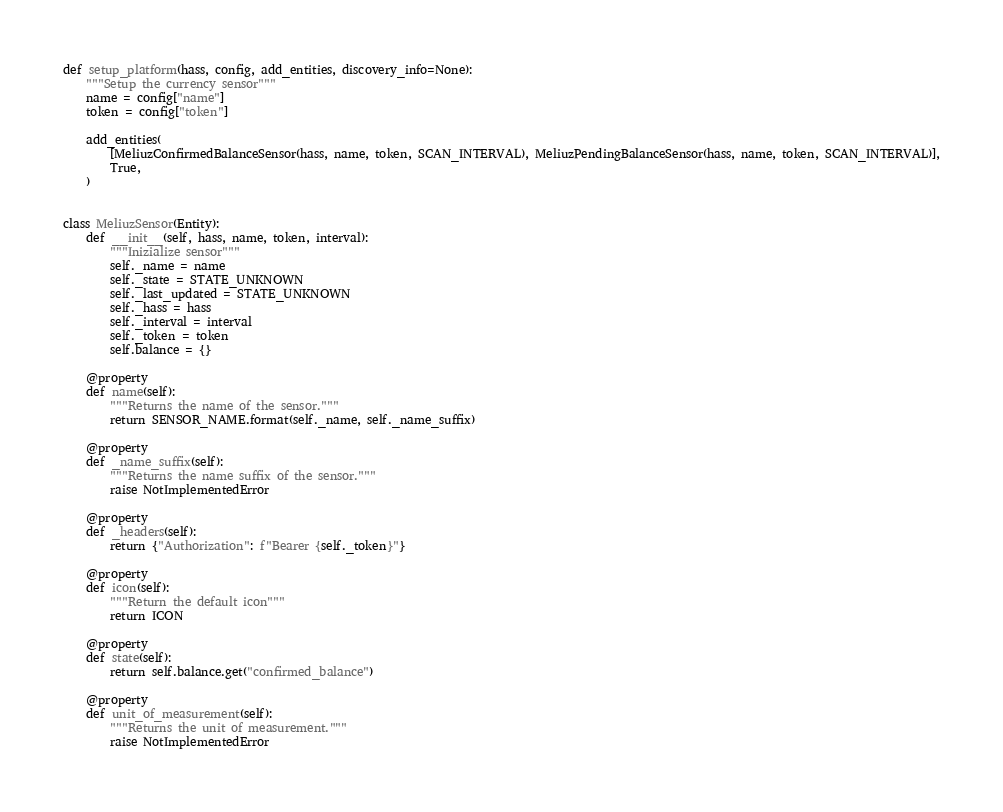Convert code to text. <code><loc_0><loc_0><loc_500><loc_500><_Python_>def setup_platform(hass, config, add_entities, discovery_info=None):
    """Setup the currency sensor"""
    name = config["name"]
    token = config["token"]

    add_entities(
        [MeliuzConfirmedBalanceSensor(hass, name, token, SCAN_INTERVAL), MeliuzPendingBalanceSensor(hass, name, token, SCAN_INTERVAL)],
        True,
    )


class MeliuzSensor(Entity):
    def __init__(self, hass, name, token, interval):
        """Inizialize sensor"""
        self._name = name
        self._state = STATE_UNKNOWN
        self._last_updated = STATE_UNKNOWN
        self._hass = hass
        self._interval = interval
        self._token = token
        self.balance = {}

    @property
    def name(self):
        """Returns the name of the sensor."""
        return SENSOR_NAME.format(self._name, self._name_suffix)

    @property
    def _name_suffix(self):
        """Returns the name suffix of the sensor."""
        raise NotImplementedError

    @property
    def _headers(self):
        return {"Authorization": f"Bearer {self._token}"}

    @property
    def icon(self):
        """Return the default icon"""
        return ICON

    @property
    def state(self):
        return self.balance.get("confirmed_balance")

    @property
    def unit_of_measurement(self):
        """Returns the unit of measurement."""
        raise NotImplementedError
</code> 